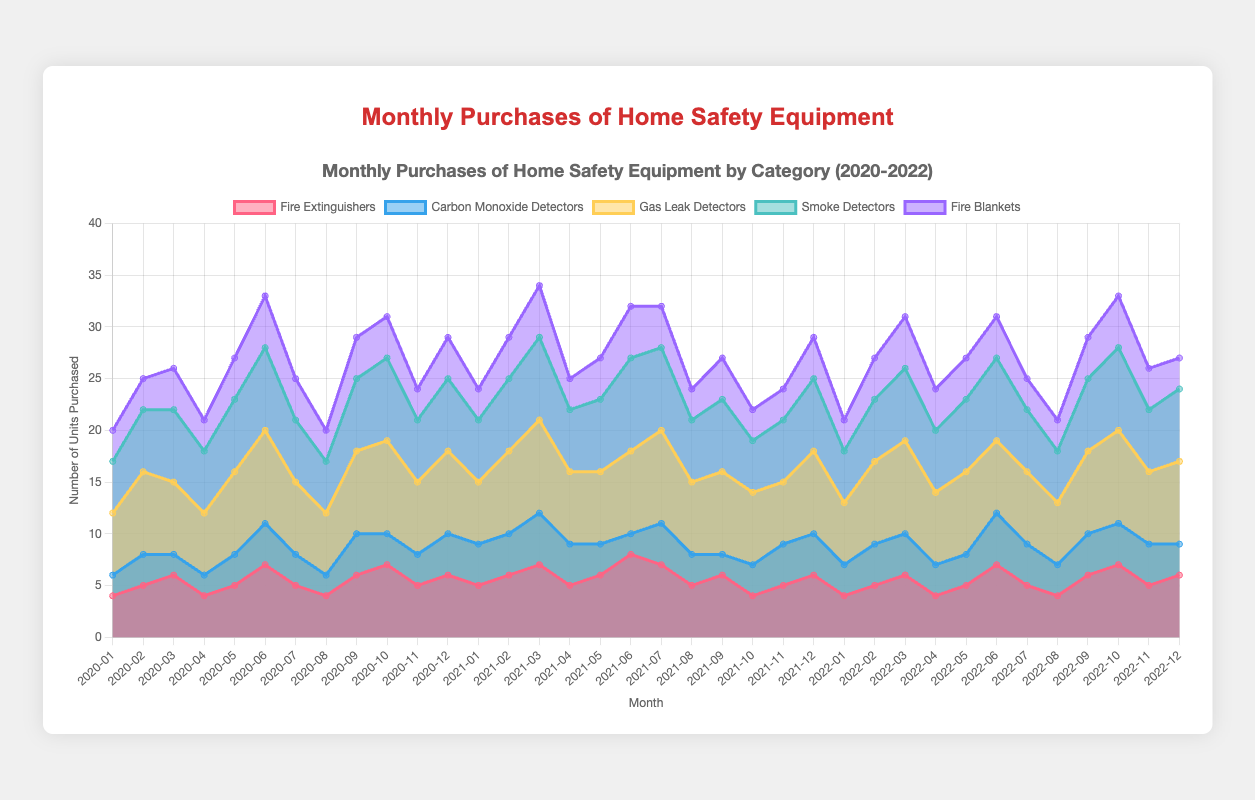What's the highest number of units purchased for Smoke Detectors in any month? The maximum value for Smoke Detectors across all months must be identified. This value is 9, which occurs in June 2021 and July 2021.
Answer: 9 Which category had the most significant increase in purchases from the previous month at any point? To find this, compare the differences between consecutive months for all categories. The greatest increase is from July 2021 to August 2021 for Smoke Detectors, where purchases increase from 7 to 9 units, a change of 2 units.
Answer: Smoke Detectors What was the total number of purchases for Carbon Monoxide Detectors in 2021? Adding the monthly values for Carbon Monoxide Detectors in 2021: 4 + 4 + 5 + 4 + 3 + 2 + 4 + 3 + 2 + 3 + 4 + 4 = 42 units purchased.
Answer: 42 How many more units of Fire Extinguishers were purchased in December 2022 compared to December 2020? Subtract the December 2020 value (6 units) from the December 2022 value (6 units): 6 - 6 = 0.
Answer: 0 In what month was the highest number of Gas Leak Detectors purchased? The peak value of Gas Leak Detectors is 9 units, which occurs in June 2020, October 2020, and June 2021.
Answer: June 2020, October 2020, June 2021 Which month had the lowest number of total units purchased across all categories in 2020? Find the sums of purchases for each month in 2020 and identify the smallest sum. January 2020 has the lowest total: 4 + 2 + 6 + 5 + 3 = 20 units.
Answer: January 2020 Across all months, which safety equipment was most frequently the highest purchased each month? Compare monthly purchases for all categories to see which one often reached the highest value. Gas Leak Detectors most frequently were the highest purchased each month.
Answer: Gas Leak Detectors What is the average number of Fire Blankets purchased per month in 2021? Add the monthly values of Fire Blankets in 2021 and divide by 12. (3 + 4 + 5 + 3 + 4 + 5 + 4 + 3 + 4 + 3 + 3 + 4) / 12 = 4 units per month on average.
Answer: 4 Are there more months where the purchases of Carbon Monoxide Detectors exceed those of Fire Extinguishers? Analyze and compare monthly values across the entire period; Carbon Monoxide Detectors exceed Fire Extinguishers in fewer months (15 times).
Answer: No 